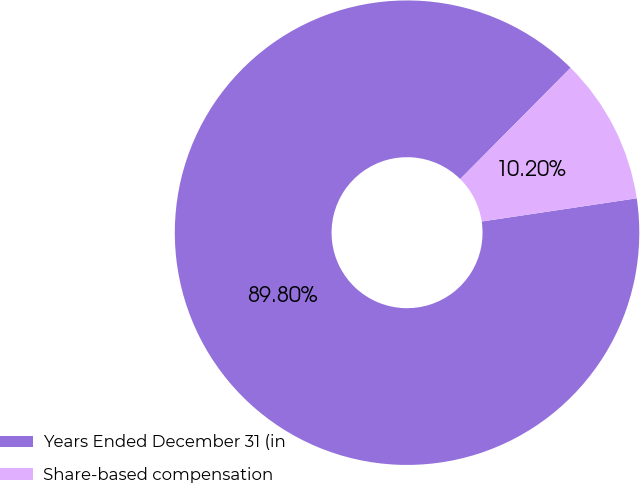<chart> <loc_0><loc_0><loc_500><loc_500><pie_chart><fcel>Years Ended December 31 (in<fcel>Share-based compensation<nl><fcel>89.8%<fcel>10.2%<nl></chart> 